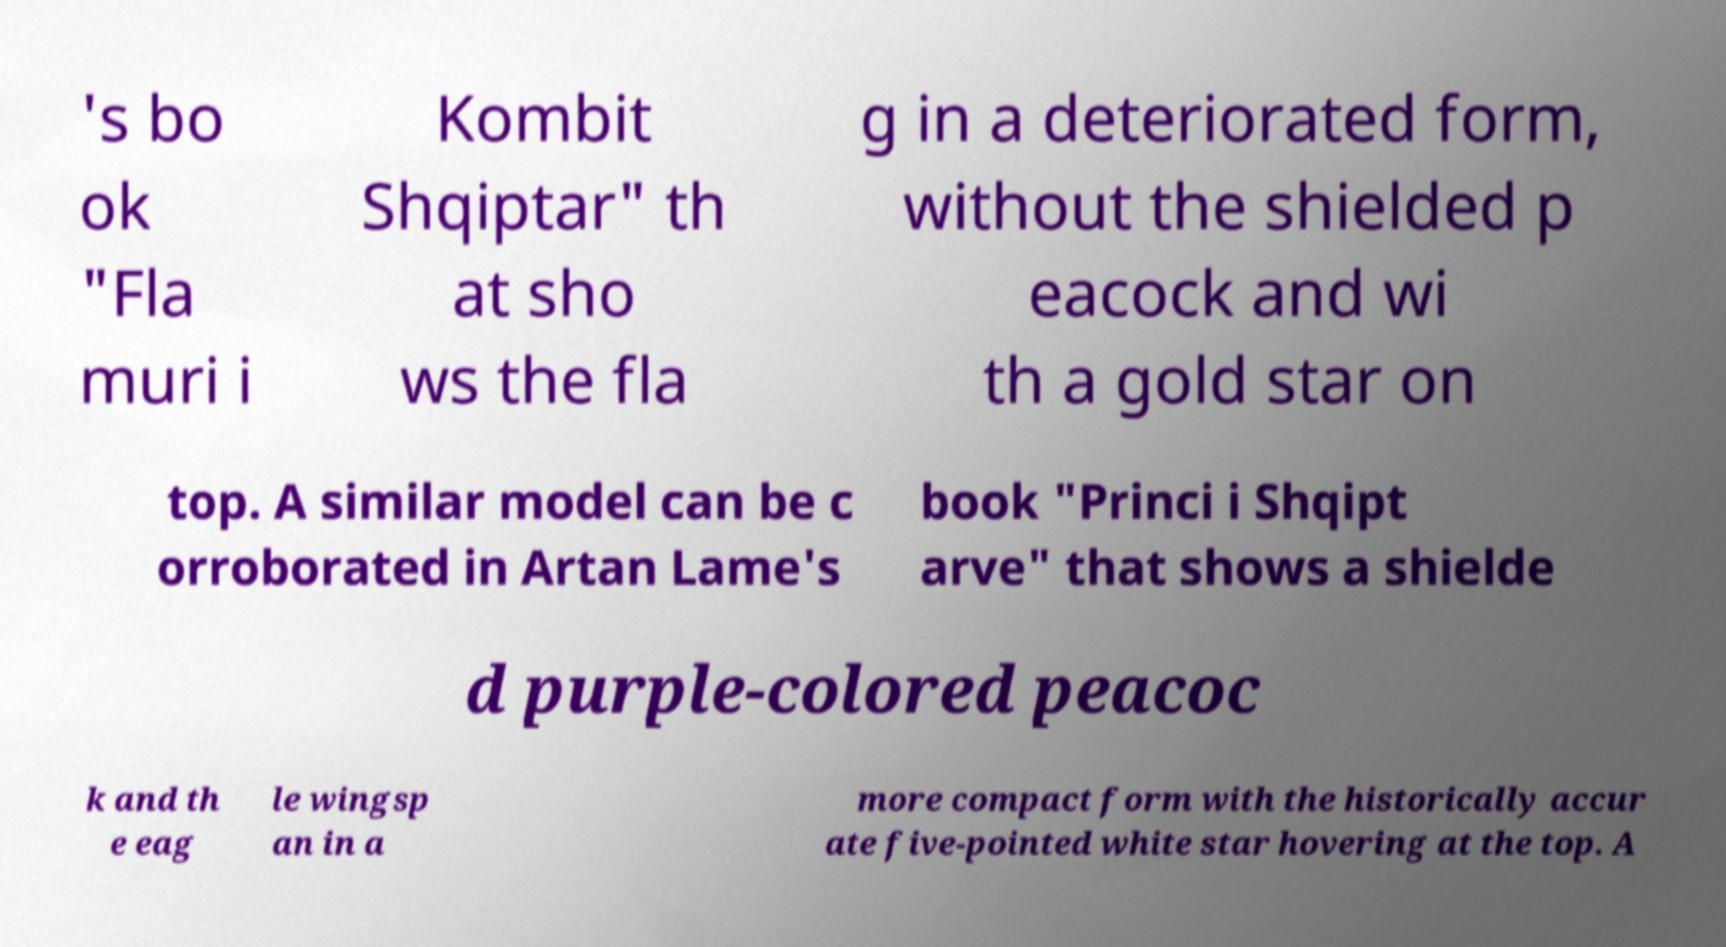There's text embedded in this image that I need extracted. Can you transcribe it verbatim? 's bo ok "Fla muri i Kombit Shqiptar" th at sho ws the fla g in a deteriorated form, without the shielded p eacock and wi th a gold star on top. A similar model can be c orroborated in Artan Lame's book "Princi i Shqipt arve" that shows a shielde d purple-colored peacoc k and th e eag le wingsp an in a more compact form with the historically accur ate five-pointed white star hovering at the top. A 